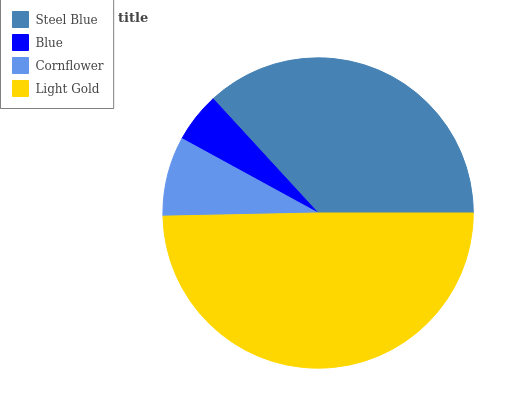Is Blue the minimum?
Answer yes or no. Yes. Is Light Gold the maximum?
Answer yes or no. Yes. Is Cornflower the minimum?
Answer yes or no. No. Is Cornflower the maximum?
Answer yes or no. No. Is Cornflower greater than Blue?
Answer yes or no. Yes. Is Blue less than Cornflower?
Answer yes or no. Yes. Is Blue greater than Cornflower?
Answer yes or no. No. Is Cornflower less than Blue?
Answer yes or no. No. Is Steel Blue the high median?
Answer yes or no. Yes. Is Cornflower the low median?
Answer yes or no. Yes. Is Blue the high median?
Answer yes or no. No. Is Steel Blue the low median?
Answer yes or no. No. 